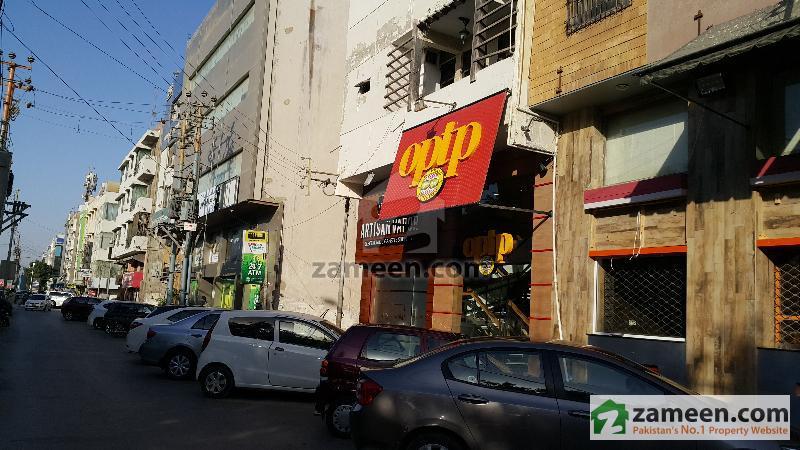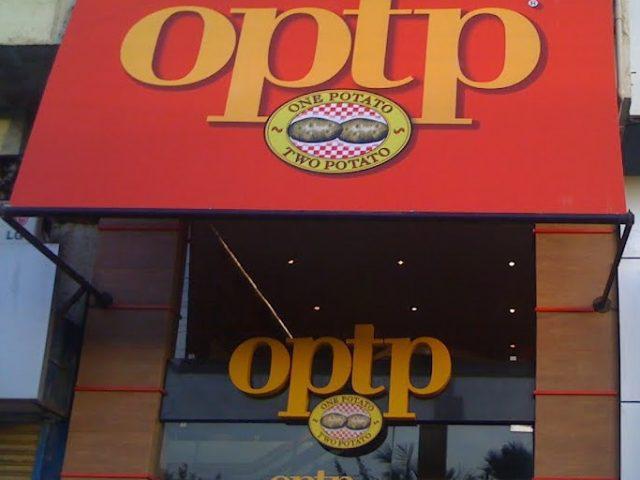The first image is the image on the left, the second image is the image on the right. Assess this claim about the two images: "There are at least three cars in one image.". Correct or not? Answer yes or no. Yes. The first image is the image on the left, the second image is the image on the right. Assess this claim about the two images: "There are people in both images.". Correct or not? Answer yes or no. No. 